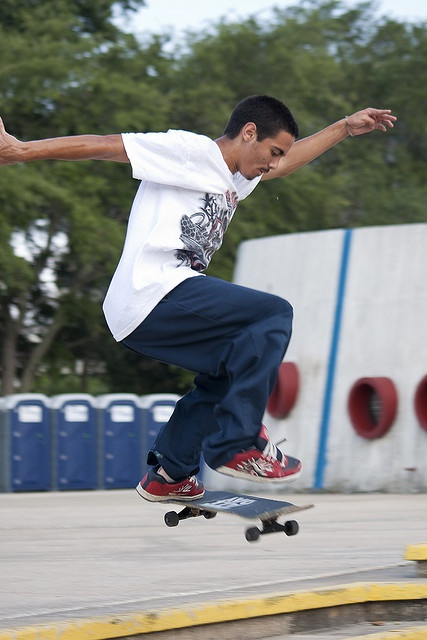Describe the objects in this image and their specific colors. I can see people in black, white, navy, and brown tones and skateboard in black, gray, and darkgray tones in this image. 